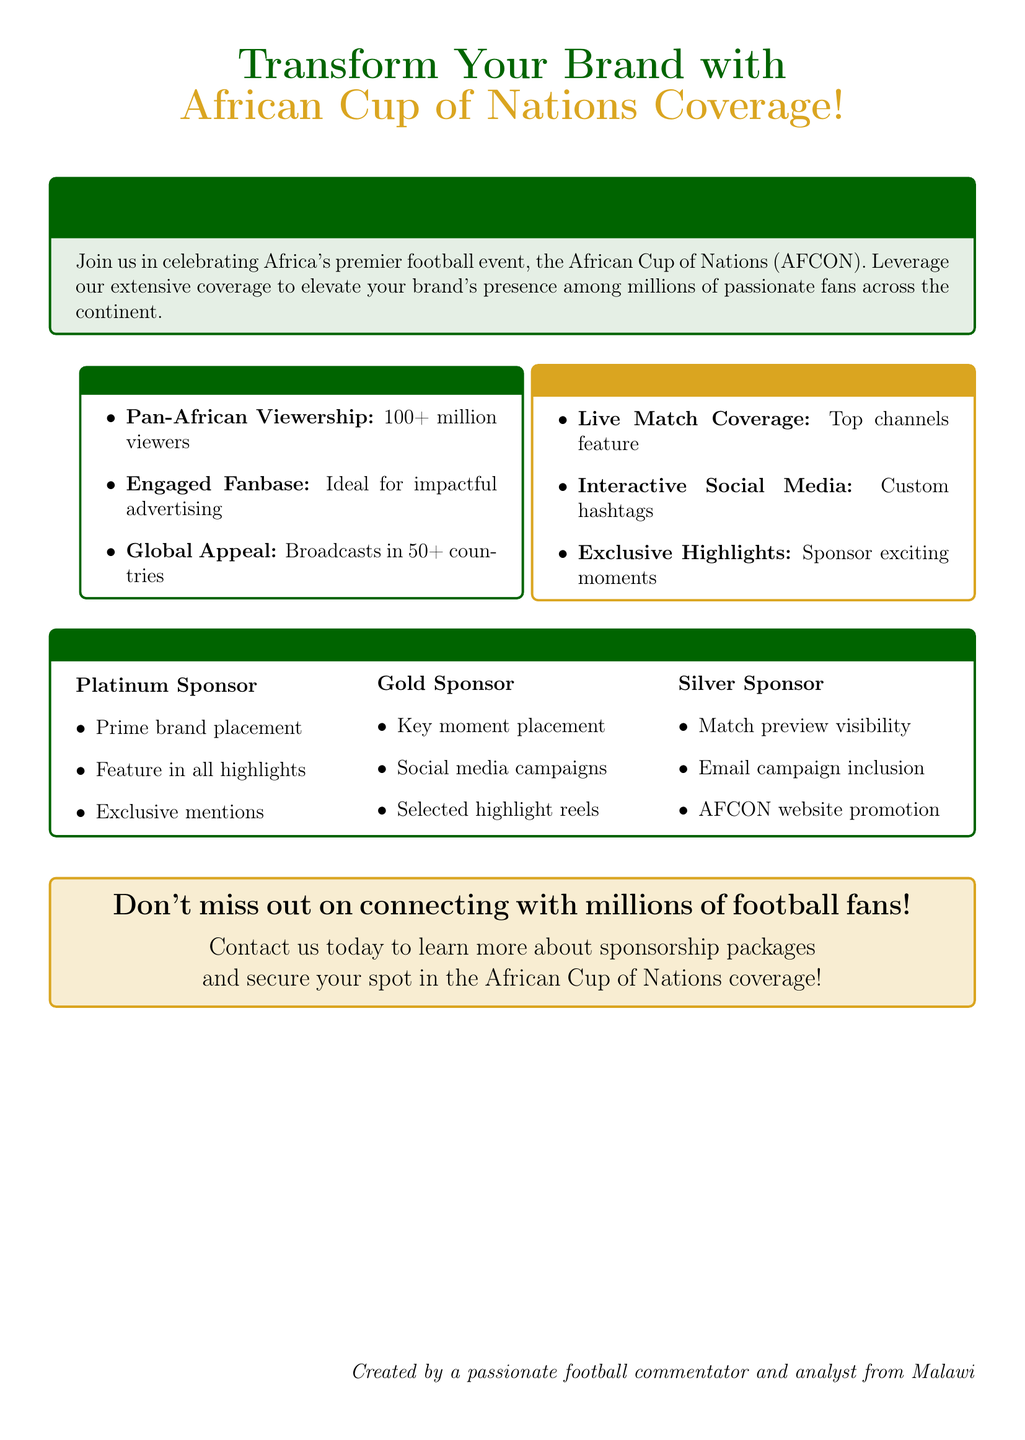What is the audience reach for the AFCON coverage? The document specifies the audience reach as "100+ million viewers."
Answer: 100+ million viewers How many countries broadcast the AFCON? The document states that broadcasts are in "50+ countries."
Answer: 50+ countries What type of content can sponsors highlight? The document mentions sponsors can highlight "exciting moments."
Answer: exciting moments What is included in the Platinum Sponsor package? The Platinum Sponsor package includes "Prime brand placement, Feature in all highlights, Exclusive mentions."
Answer: Prime brand placement, Feature in all highlights, Exclusive mentions What social media aspect is mentioned for engagement? The document emphasizes "Interactive Social Media" with custom hashtags.
Answer: Interactive Social Media How many sponsorship levels are available? The document outlines three sponsorship levels: Platinum, Gold, and Silver.
Answer: Three levels What kind of audience does the AFCON coverage target? The target audience is described as "millions of passionate fans across the continent."
Answer: millions of passionate fans across the continent What does the Gold Sponsor package include for advertising? The Gold Sponsor package includes "Social media campaigns."
Answer: Social media campaigns 